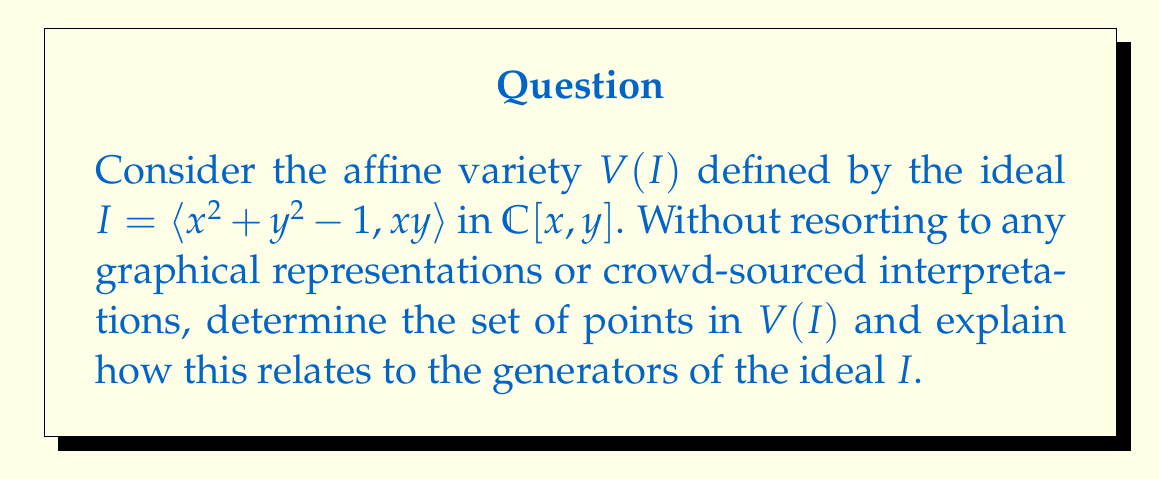Show me your answer to this math problem. 1. The ideal $I$ is generated by two polynomials: $f_1 = x^2 + y^2 - 1$ and $f_2 = xy$.

2. To find $V(I)$, we need to solve the system of equations:
   $$\begin{cases}
   x^2 + y^2 - 1 = 0 \\
   xy = 0
   \end{cases}$$

3. From $xy = 0$, we can deduce that either $x = 0$ or $y = 0$ (or both).

4. Case 1: If $x = 0$, substituting into $x^2 + y^2 - 1 = 0$:
   $$y^2 - 1 = 0 \implies y = \pm 1$$

5. Case 2: If $y = 0$, substituting into $x^2 + y^2 - 1 = 0$:
   $$x^2 - 1 = 0 \implies x = \pm 1$$

6. The points satisfying both equations are therefore:
   $$(0, 1), (0, -1), (1, 0), (-1, 0)$$

7. These four points form the variety $V(I)$.

8. The relationship between $V(I)$ and $I$ is as follows:
   - $f_1 = x^2 + y^2 - 1 = 0$ defines a circle in $\mathbb{C}^2$.
   - $f_2 = xy = 0$ defines the union of the x-axis and y-axis.
   - The intersection of these two geometric objects gives us $V(I)$.

9. This demonstrates the fundamental principle in algebraic geometry that varieties are determined by their defining ideals, and conversely, ideals can be understood through their associated varieties.
Answer: $V(I) = \{(0, 1), (0, -1), (1, 0), (-1, 0)\}$ 